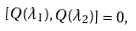Convert formula to latex. <formula><loc_0><loc_0><loc_500><loc_500>[ Q ( \lambda _ { 1 } ) , Q ( \lambda _ { 2 } ) ] = 0 ,</formula> 